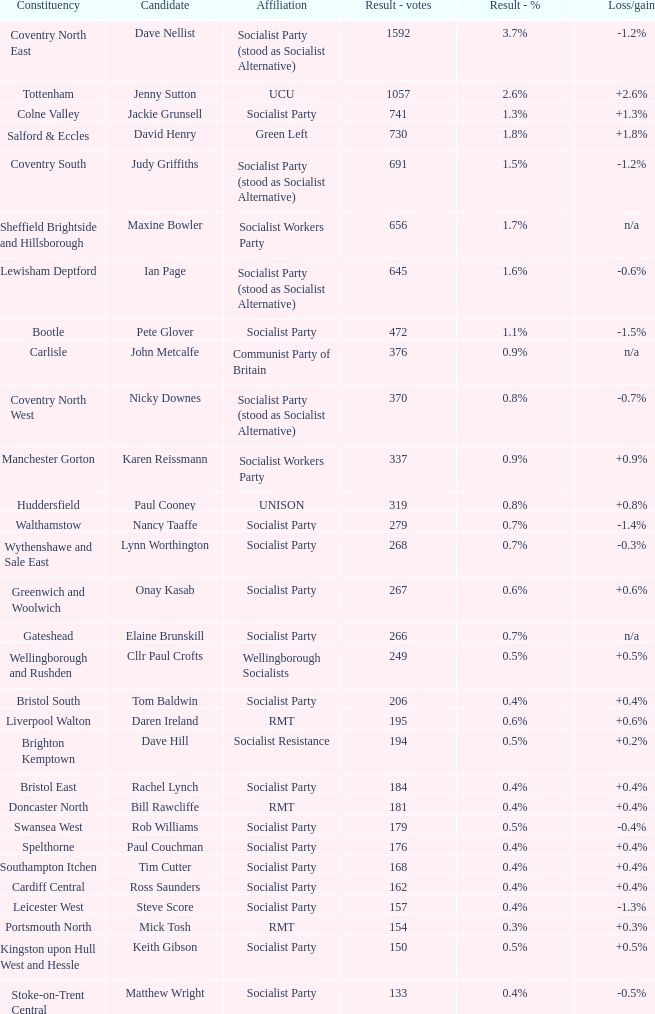How many values for district for the vote outcome of 162? 1.0. 